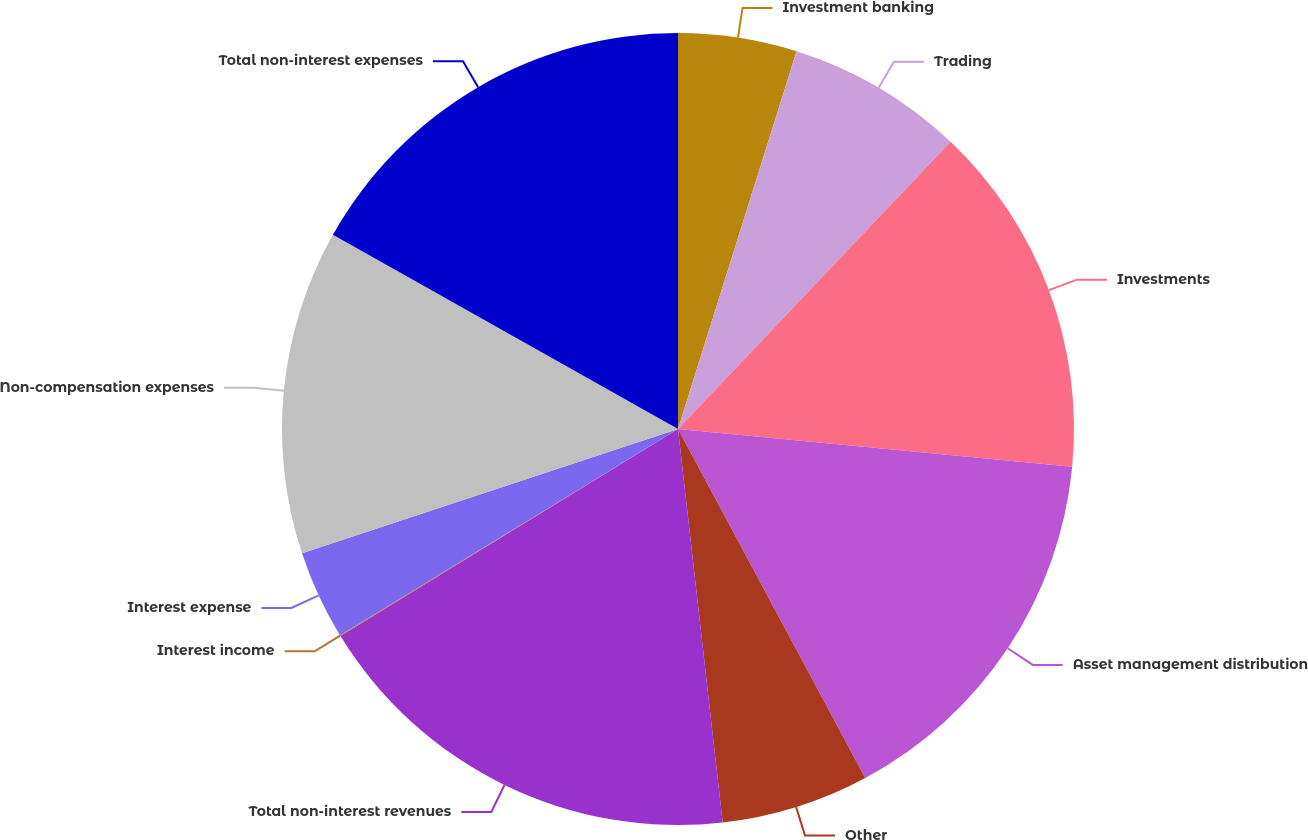<chart> <loc_0><loc_0><loc_500><loc_500><pie_chart><fcel>Investment banking<fcel>Trading<fcel>Investments<fcel>Asset management distribution<fcel>Other<fcel>Total non-interest revenues<fcel>Interest income<fcel>Interest expense<fcel>Non-compensation expenses<fcel>Total non-interest expenses<nl><fcel>4.84%<fcel>7.24%<fcel>14.44%<fcel>15.64%<fcel>6.04%<fcel>18.04%<fcel>0.04%<fcel>3.64%<fcel>13.24%<fcel>16.84%<nl></chart> 